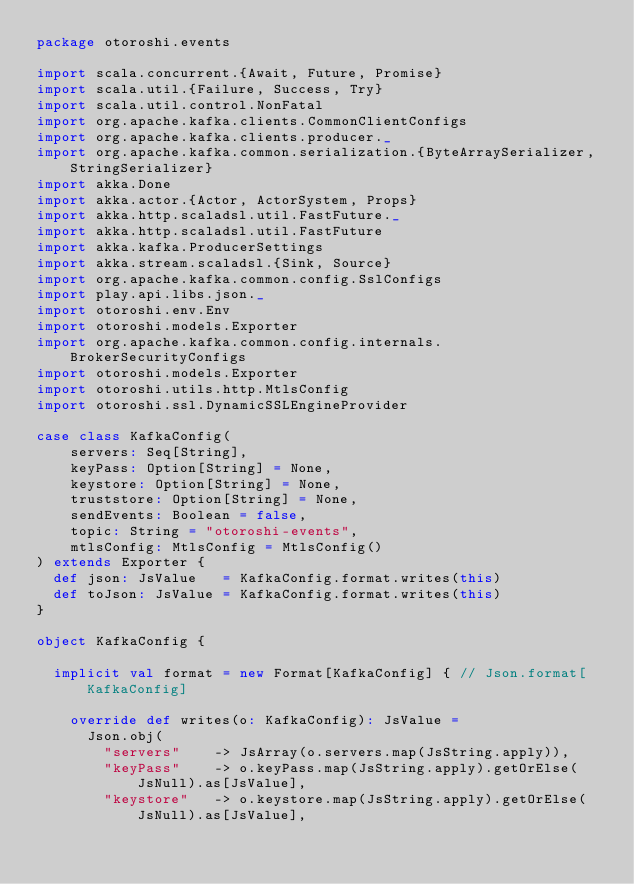<code> <loc_0><loc_0><loc_500><loc_500><_Scala_>package otoroshi.events

import scala.concurrent.{Await, Future, Promise}
import scala.util.{Failure, Success, Try}
import scala.util.control.NonFatal
import org.apache.kafka.clients.CommonClientConfigs
import org.apache.kafka.clients.producer._
import org.apache.kafka.common.serialization.{ByteArraySerializer, StringSerializer}
import akka.Done
import akka.actor.{Actor, ActorSystem, Props}
import akka.http.scaladsl.util.FastFuture._
import akka.http.scaladsl.util.FastFuture
import akka.kafka.ProducerSettings
import akka.stream.scaladsl.{Sink, Source}
import org.apache.kafka.common.config.SslConfigs
import play.api.libs.json._
import otoroshi.env.Env
import otoroshi.models.Exporter
import org.apache.kafka.common.config.internals.BrokerSecurityConfigs
import otoroshi.models.Exporter
import otoroshi.utils.http.MtlsConfig
import otoroshi.ssl.DynamicSSLEngineProvider

case class KafkaConfig(
    servers: Seq[String],
    keyPass: Option[String] = None,
    keystore: Option[String] = None,
    truststore: Option[String] = None,
    sendEvents: Boolean = false,
    topic: String = "otoroshi-events",
    mtlsConfig: MtlsConfig = MtlsConfig()
) extends Exporter {
  def json: JsValue   = KafkaConfig.format.writes(this)
  def toJson: JsValue = KafkaConfig.format.writes(this)
}

object KafkaConfig {

  implicit val format = new Format[KafkaConfig] { // Json.format[KafkaConfig]

    override def writes(o: KafkaConfig): JsValue =
      Json.obj(
        "servers"    -> JsArray(o.servers.map(JsString.apply)),
        "keyPass"    -> o.keyPass.map(JsString.apply).getOrElse(JsNull).as[JsValue],
        "keystore"   -> o.keystore.map(JsString.apply).getOrElse(JsNull).as[JsValue],</code> 